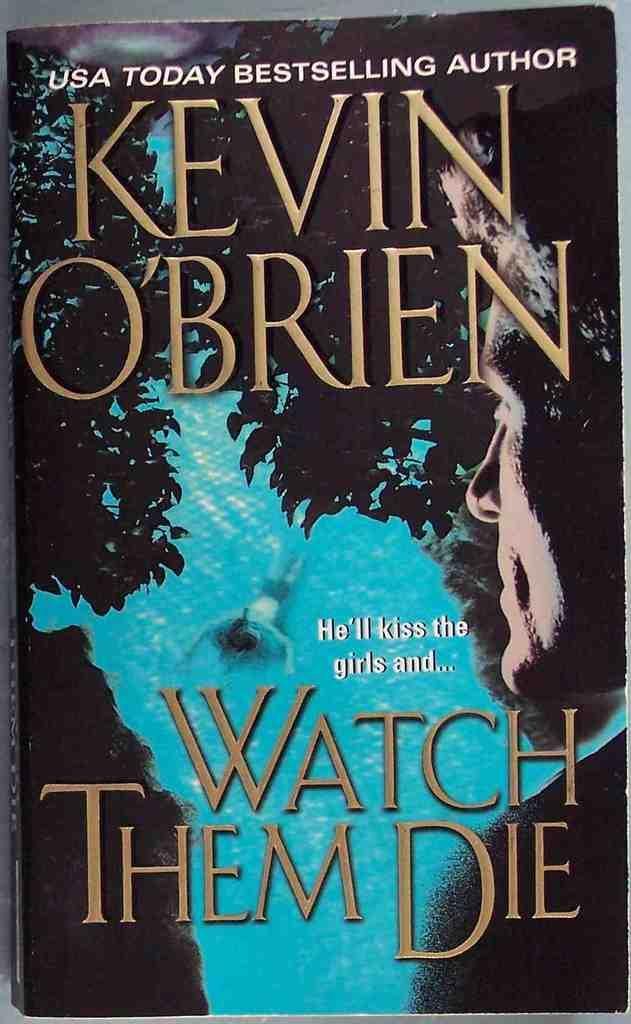What is the main subject of the image? The main subject of the image is a book cover. What can be found on the book cover? The book cover has text and images on it. How many chairs are depicted on the book cover? There are no chairs depicted on the book cover; it only features text and images related to the book. 